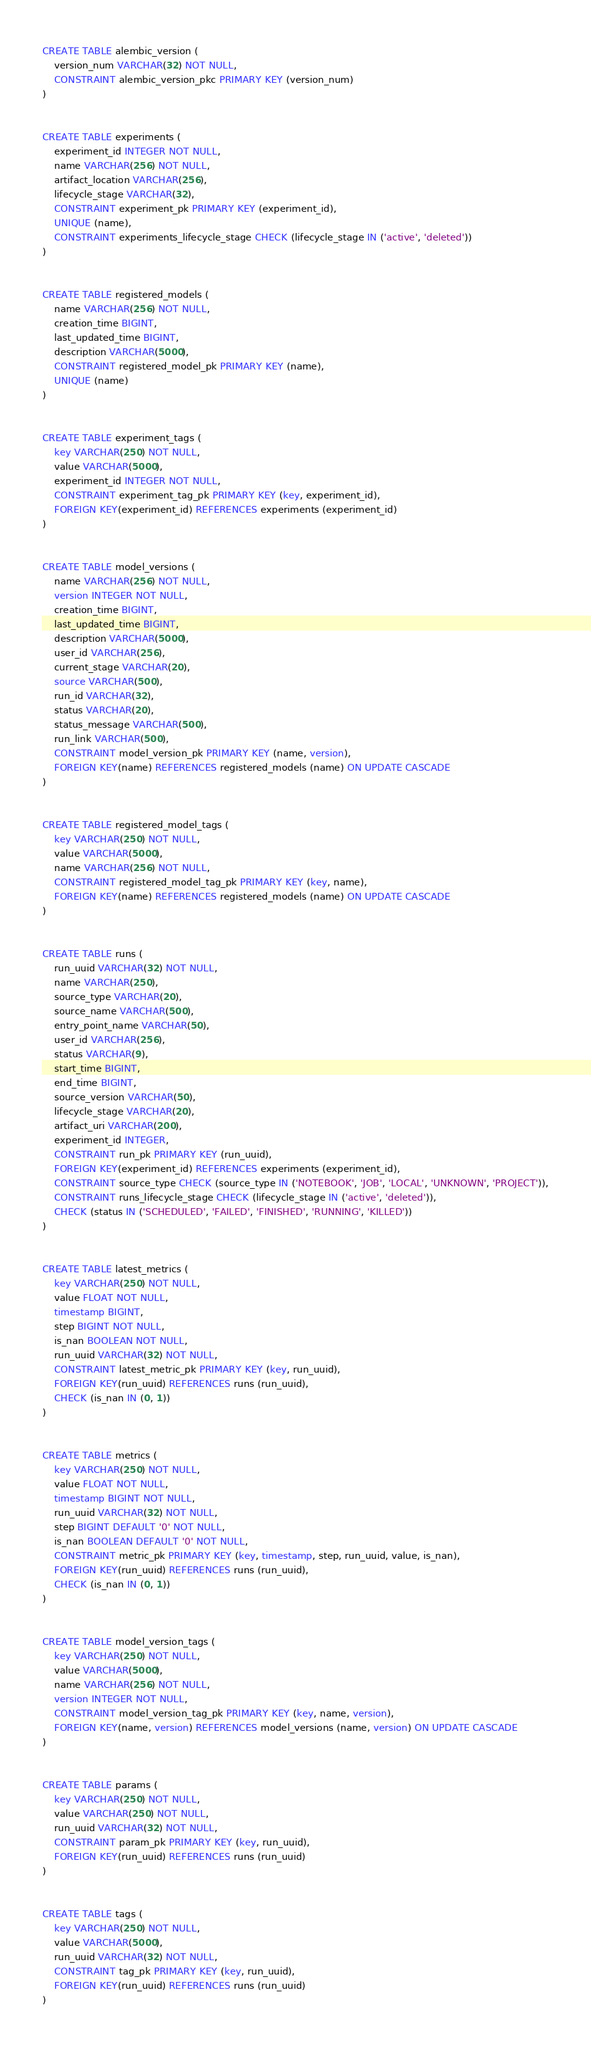<code> <loc_0><loc_0><loc_500><loc_500><_SQL_>
CREATE TABLE alembic_version (
	version_num VARCHAR(32) NOT NULL,
	CONSTRAINT alembic_version_pkc PRIMARY KEY (version_num)
)


CREATE TABLE experiments (
	experiment_id INTEGER NOT NULL,
	name VARCHAR(256) NOT NULL,
	artifact_location VARCHAR(256),
	lifecycle_stage VARCHAR(32),
	CONSTRAINT experiment_pk PRIMARY KEY (experiment_id),
	UNIQUE (name),
	CONSTRAINT experiments_lifecycle_stage CHECK (lifecycle_stage IN ('active', 'deleted'))
)


CREATE TABLE registered_models (
	name VARCHAR(256) NOT NULL,
	creation_time BIGINT,
	last_updated_time BIGINT,
	description VARCHAR(5000),
	CONSTRAINT registered_model_pk PRIMARY KEY (name),
	UNIQUE (name)
)


CREATE TABLE experiment_tags (
	key VARCHAR(250) NOT NULL,
	value VARCHAR(5000),
	experiment_id INTEGER NOT NULL,
	CONSTRAINT experiment_tag_pk PRIMARY KEY (key, experiment_id),
	FOREIGN KEY(experiment_id) REFERENCES experiments (experiment_id)
)


CREATE TABLE model_versions (
	name VARCHAR(256) NOT NULL,
	version INTEGER NOT NULL,
	creation_time BIGINT,
	last_updated_time BIGINT,
	description VARCHAR(5000),
	user_id VARCHAR(256),
	current_stage VARCHAR(20),
	source VARCHAR(500),
	run_id VARCHAR(32),
	status VARCHAR(20),
	status_message VARCHAR(500),
	run_link VARCHAR(500),
	CONSTRAINT model_version_pk PRIMARY KEY (name, version),
	FOREIGN KEY(name) REFERENCES registered_models (name) ON UPDATE CASCADE
)


CREATE TABLE registered_model_tags (
	key VARCHAR(250) NOT NULL,
	value VARCHAR(5000),
	name VARCHAR(256) NOT NULL,
	CONSTRAINT registered_model_tag_pk PRIMARY KEY (key, name),
	FOREIGN KEY(name) REFERENCES registered_models (name) ON UPDATE CASCADE
)


CREATE TABLE runs (
	run_uuid VARCHAR(32) NOT NULL,
	name VARCHAR(250),
	source_type VARCHAR(20),
	source_name VARCHAR(500),
	entry_point_name VARCHAR(50),
	user_id VARCHAR(256),
	status VARCHAR(9),
	start_time BIGINT,
	end_time BIGINT,
	source_version VARCHAR(50),
	lifecycle_stage VARCHAR(20),
	artifact_uri VARCHAR(200),
	experiment_id INTEGER,
	CONSTRAINT run_pk PRIMARY KEY (run_uuid),
	FOREIGN KEY(experiment_id) REFERENCES experiments (experiment_id),
	CONSTRAINT source_type CHECK (source_type IN ('NOTEBOOK', 'JOB', 'LOCAL', 'UNKNOWN', 'PROJECT')),
	CONSTRAINT runs_lifecycle_stage CHECK (lifecycle_stage IN ('active', 'deleted')),
	CHECK (status IN ('SCHEDULED', 'FAILED', 'FINISHED', 'RUNNING', 'KILLED'))
)


CREATE TABLE latest_metrics (
	key VARCHAR(250) NOT NULL,
	value FLOAT NOT NULL,
	timestamp BIGINT,
	step BIGINT NOT NULL,
	is_nan BOOLEAN NOT NULL,
	run_uuid VARCHAR(32) NOT NULL,
	CONSTRAINT latest_metric_pk PRIMARY KEY (key, run_uuid),
	FOREIGN KEY(run_uuid) REFERENCES runs (run_uuid),
	CHECK (is_nan IN (0, 1))
)


CREATE TABLE metrics (
	key VARCHAR(250) NOT NULL,
	value FLOAT NOT NULL,
	timestamp BIGINT NOT NULL,
	run_uuid VARCHAR(32) NOT NULL,
	step BIGINT DEFAULT '0' NOT NULL,
	is_nan BOOLEAN DEFAULT '0' NOT NULL,
	CONSTRAINT metric_pk PRIMARY KEY (key, timestamp, step, run_uuid, value, is_nan),
	FOREIGN KEY(run_uuid) REFERENCES runs (run_uuid),
	CHECK (is_nan IN (0, 1))
)


CREATE TABLE model_version_tags (
	key VARCHAR(250) NOT NULL,
	value VARCHAR(5000),
	name VARCHAR(256) NOT NULL,
	version INTEGER NOT NULL,
	CONSTRAINT model_version_tag_pk PRIMARY KEY (key, name, version),
	FOREIGN KEY(name, version) REFERENCES model_versions (name, version) ON UPDATE CASCADE
)


CREATE TABLE params (
	key VARCHAR(250) NOT NULL,
	value VARCHAR(250) NOT NULL,
	run_uuid VARCHAR(32) NOT NULL,
	CONSTRAINT param_pk PRIMARY KEY (key, run_uuid),
	FOREIGN KEY(run_uuid) REFERENCES runs (run_uuid)
)


CREATE TABLE tags (
	key VARCHAR(250) NOT NULL,
	value VARCHAR(5000),
	run_uuid VARCHAR(32) NOT NULL,
	CONSTRAINT tag_pk PRIMARY KEY (key, run_uuid),
	FOREIGN KEY(run_uuid) REFERENCES runs (run_uuid)
)

</code> 